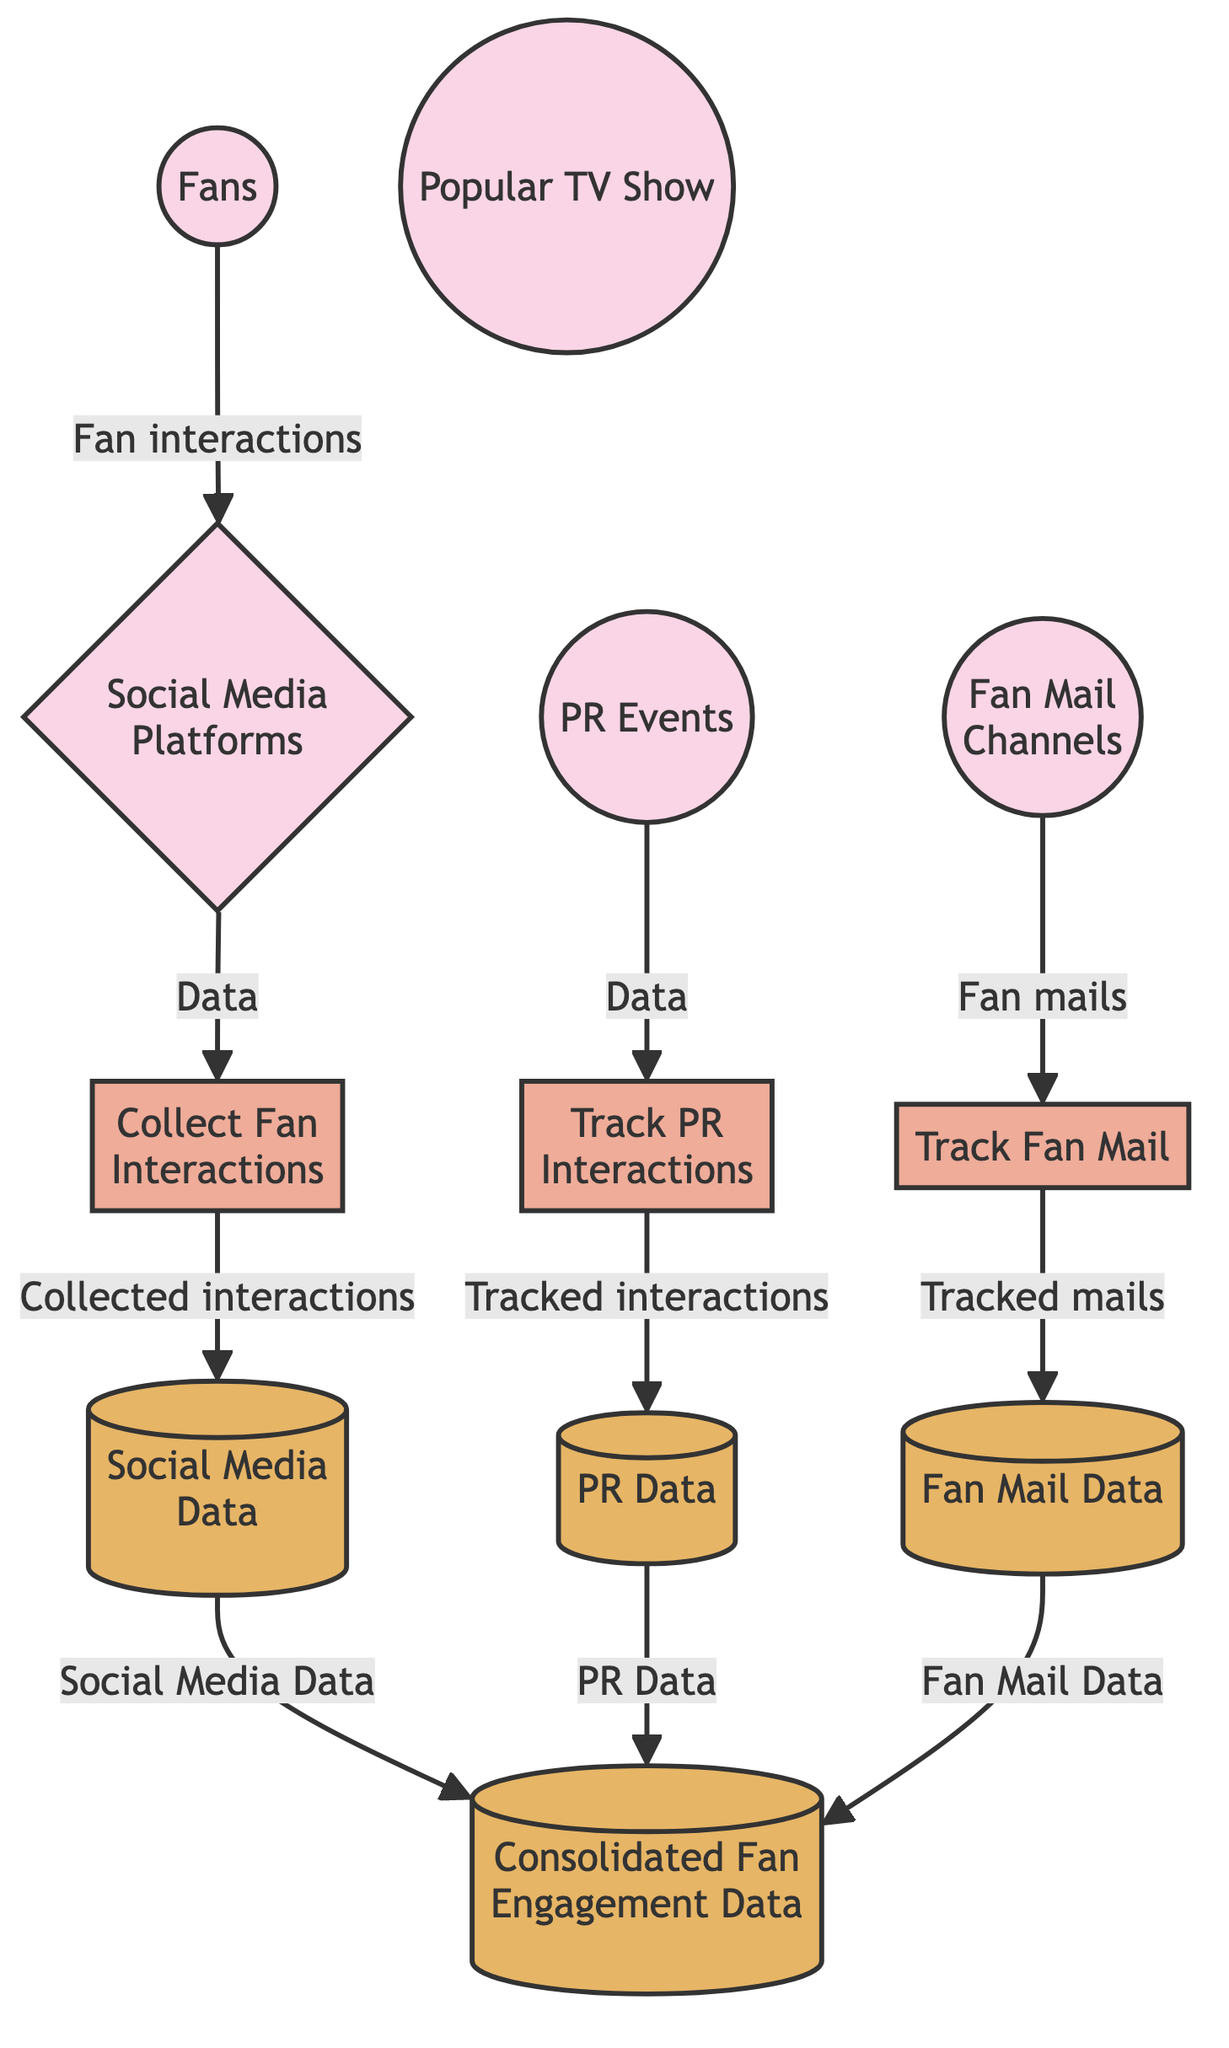What are the entities in the diagram? The diagram includes entities such as Fans, Popular TV Show, Social Media Platforms, PR Events, and Fan Mail Channels. These entities represent the main components involved in the data flow relating to fan engagement.
Answer: Fans, Popular TV Show, Social Media Platforms, PR Events, Fan Mail Channels How many processes are shown in the diagram? The diagram features three processes: Collect Fan Interactions, Track PR Interactions, and Track Fan Mail. Counting these individually gives a total of three processes.
Answer: 3 What type of data is collected from Social Media Platforms? Data captured from Social Media Platforms falls under the category of Social Media Data, which consolidates interactions from various social media channels.
Answer: Social Media Data Which store receives the tracked information from PR Events? The tracked information from PR Events is directed to the PR Data Store, which holds all the records of interactions related to public relations activities.
Answer: PR Data Which data flows consolidate into the Consolidated Fan Engagement Data Store? The flows that consolidate into the Consolidated Fan Engagement Data Store include Social Media Data, PR Data, and Fan Mail Data. These stores combine various types of engagement metrics into one unified repository.
Answer: Social Media Data, PR Data, Fan Mail Data What is the relationship between Fans and Social Media Platforms? Fans interact with Social Media Platforms, as depicted by the direction of the flow from Fans to Social Media Platforms that signifies the fans’ engagement through social media interactions.
Answer: Fan interactions How many data stores are depicted in the diagram? There are four data stores represented in the diagram: Social Media Data, PR Data, Fan Mail Data, and Consolidated Fan Engagement Data. Each of these stores collects and retains specific types of engagement data.
Answer: 4 What is the purpose of the Collect Fan Interactions process? The purpose of the Collect Fan Interactions process is to gather fan interactions from Social Media Platforms, which are then processed and stored in Social Media Data.
Answer: Gather fan interactions Which channel is involved in tracking fan mail? The tracking of fan mail is processed through the Fan Mail Channels, which directly feeds into the Tracking Fan Mail process to capture and record all incoming fan correspondence.
Answer: Fan Mail Channels 